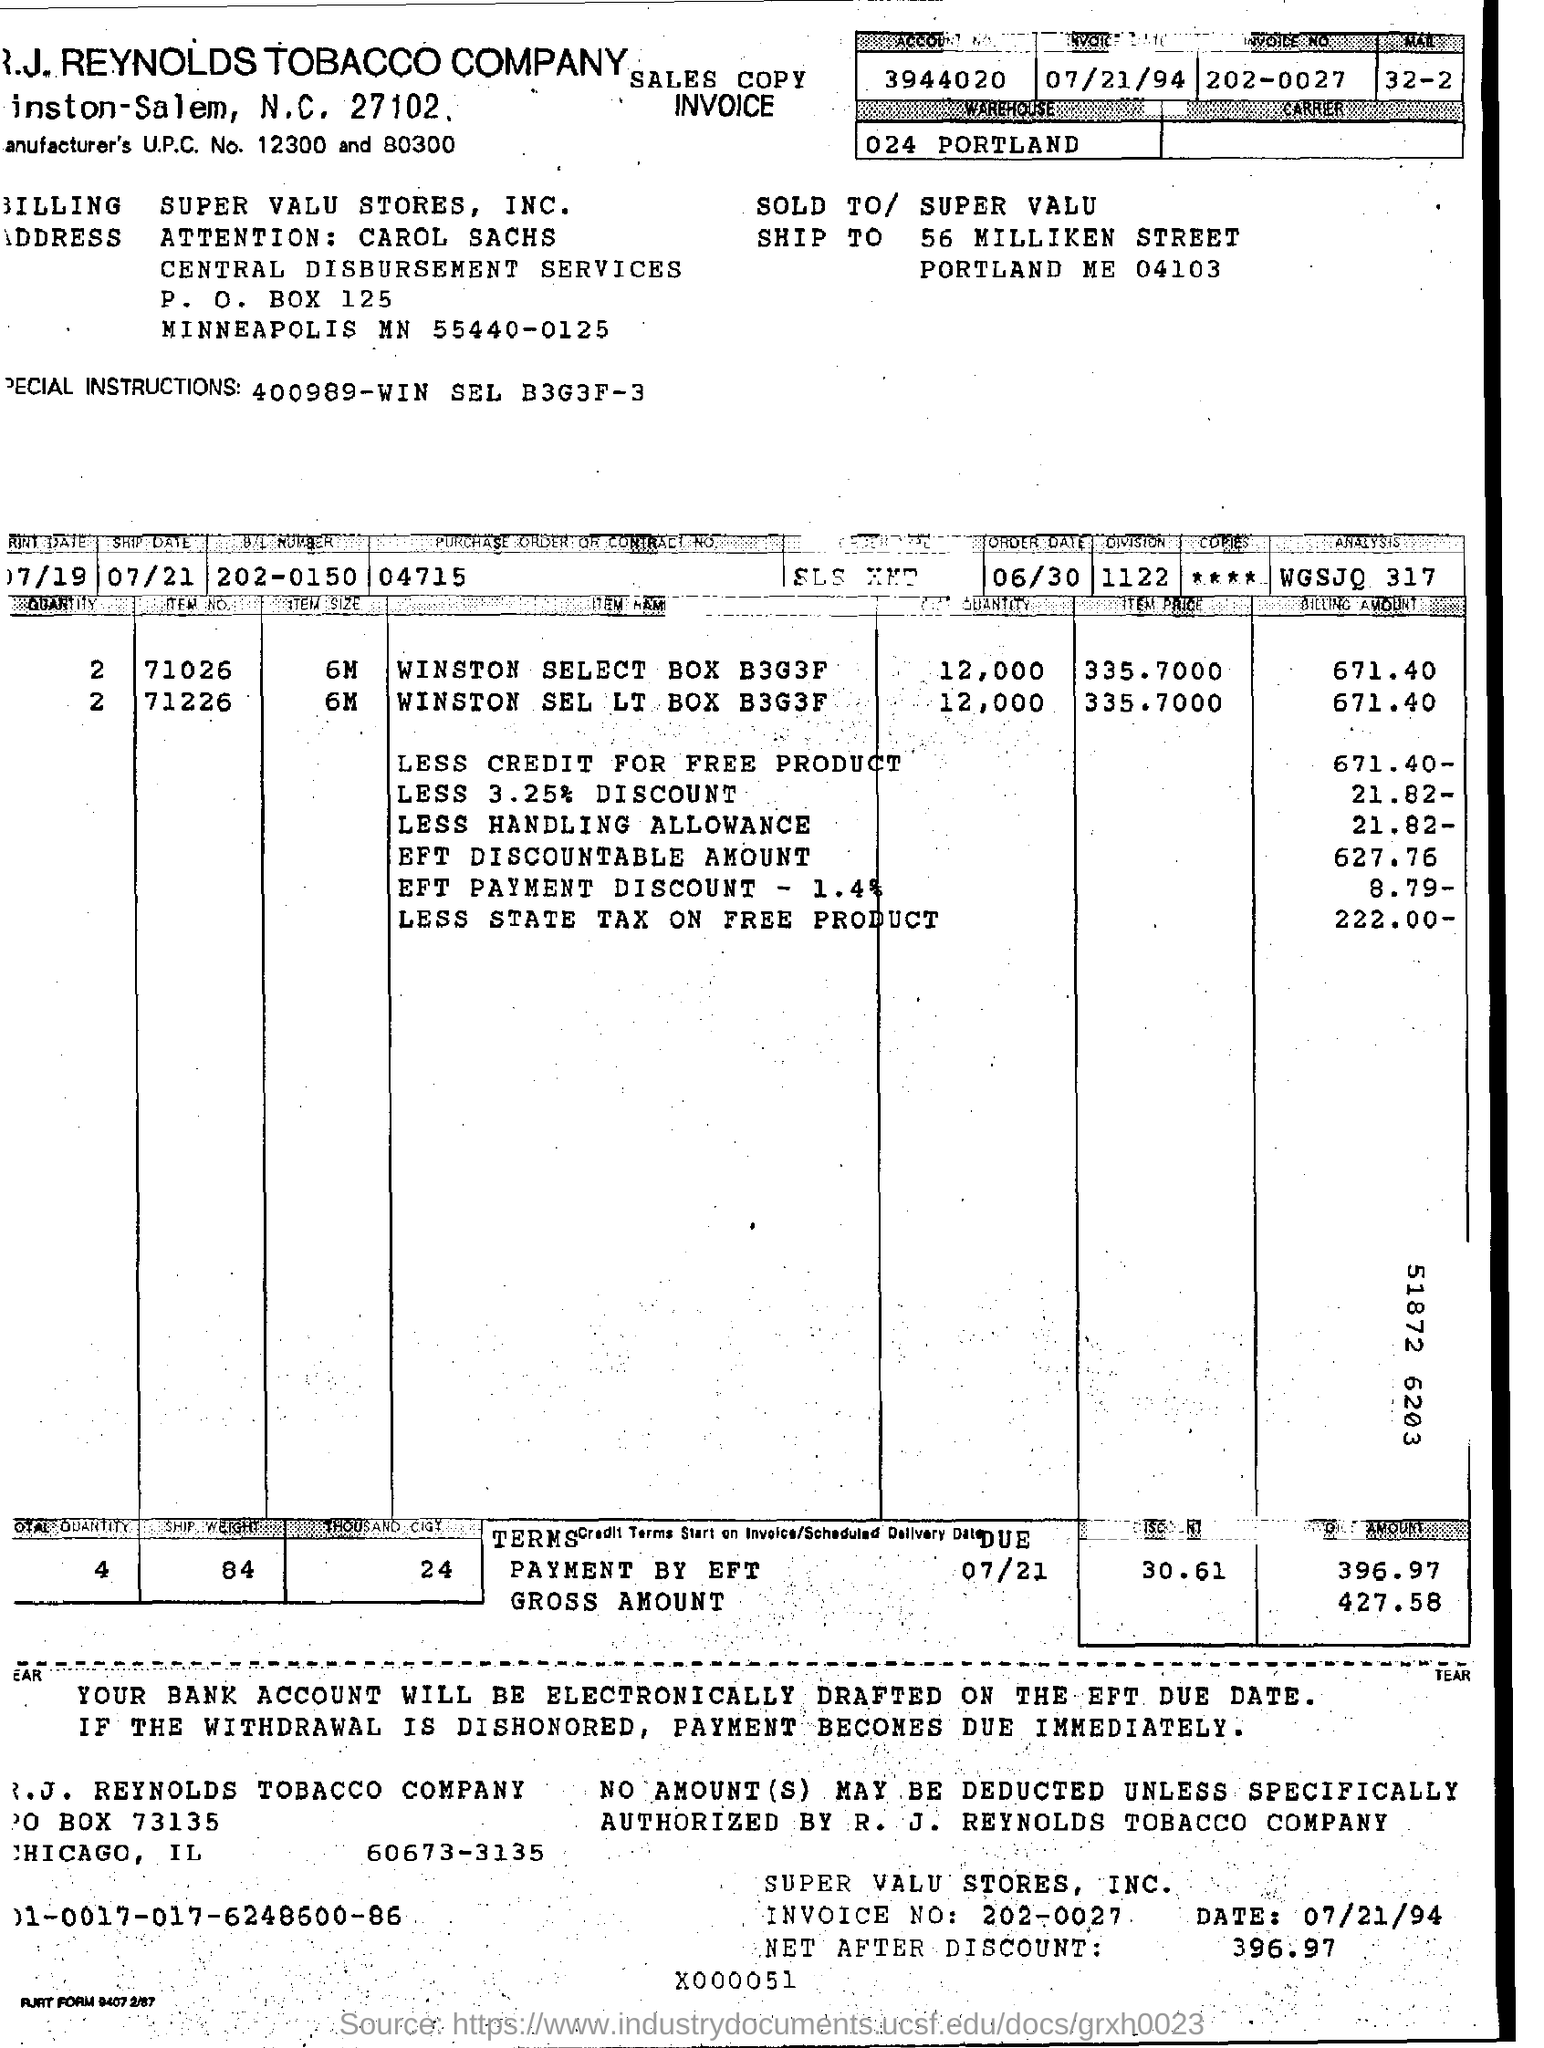What is the account Number?
Keep it short and to the point. 3944020. What is the invoice date?
Your answer should be compact. 07/21/94. What is the invoice No.?
Ensure brevity in your answer.  202-0027. When is the ship date?
Offer a terse response. 07/21. What is the B/L Number?
Your response must be concise. 202-0150. What is the purchase order or Contract No.?
Make the answer very short. 04715. What is the Quantity?
Offer a terse response. 4. What is the ship weight?
Give a very brief answer. 84. Where is the warehouse?
Your answer should be compact. 024 Portland. What is the Gross amount?
Provide a succinct answer. 427.58. 